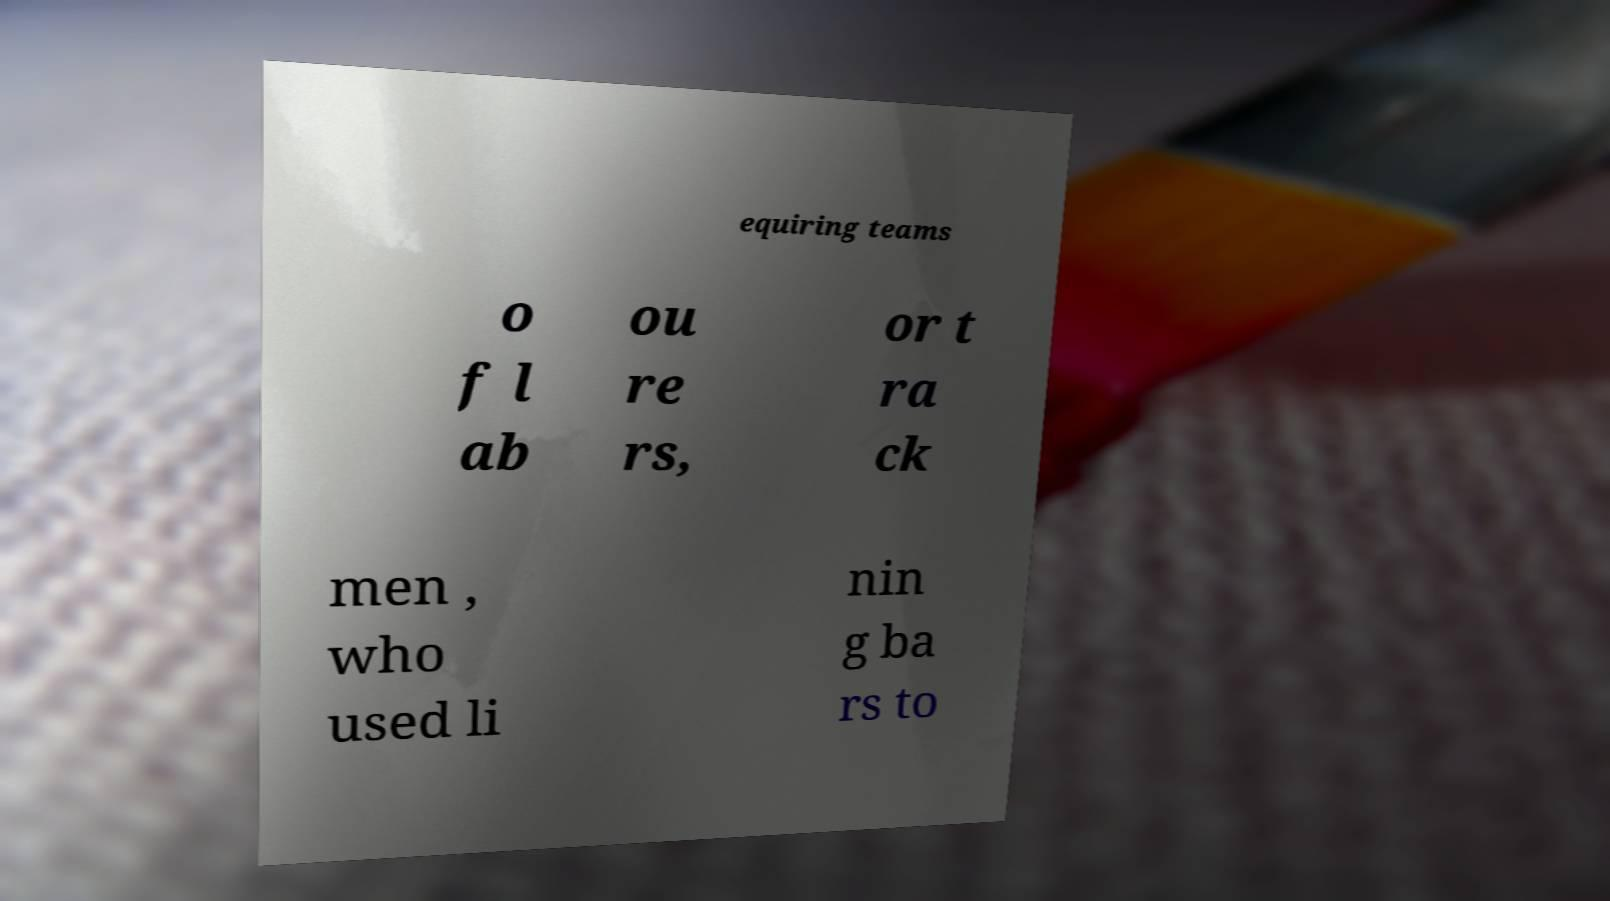Could you assist in decoding the text presented in this image and type it out clearly? equiring teams o f l ab ou re rs, or t ra ck men , who used li nin g ba rs to 